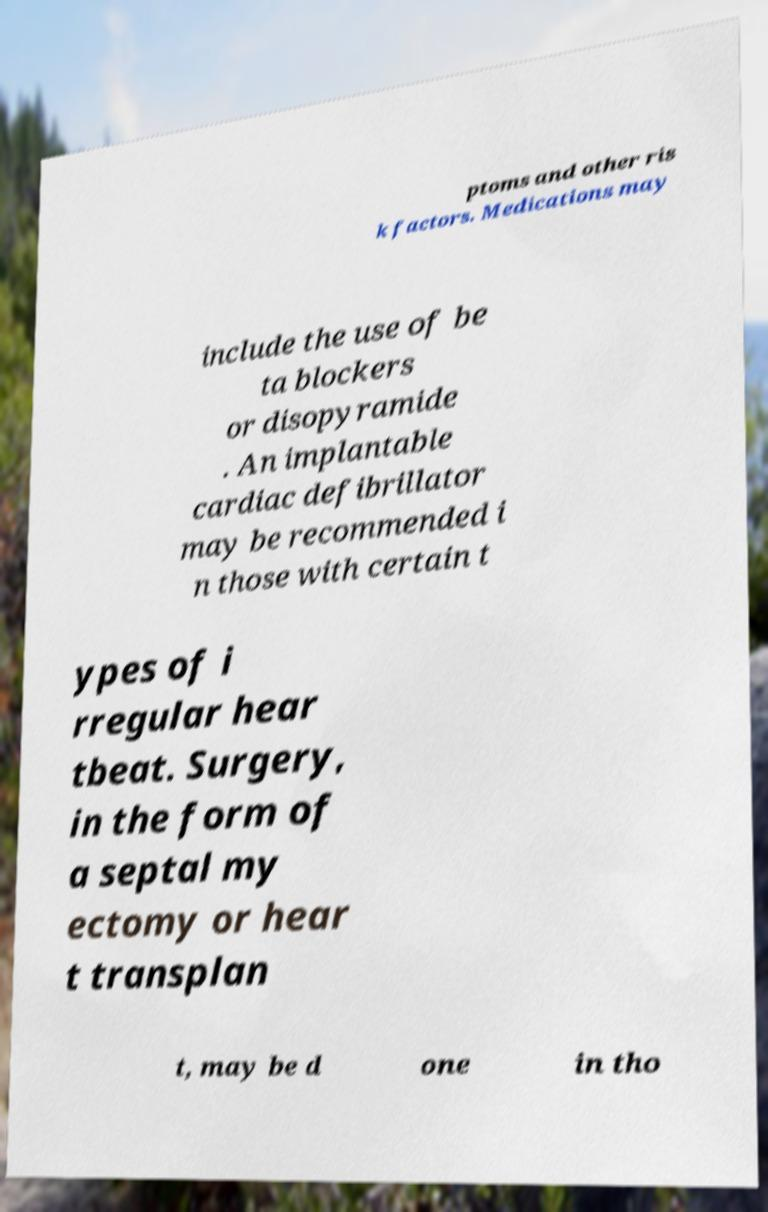Could you extract and type out the text from this image? ptoms and other ris k factors. Medications may include the use of be ta blockers or disopyramide . An implantable cardiac defibrillator may be recommended i n those with certain t ypes of i rregular hear tbeat. Surgery, in the form of a septal my ectomy or hear t transplan t, may be d one in tho 